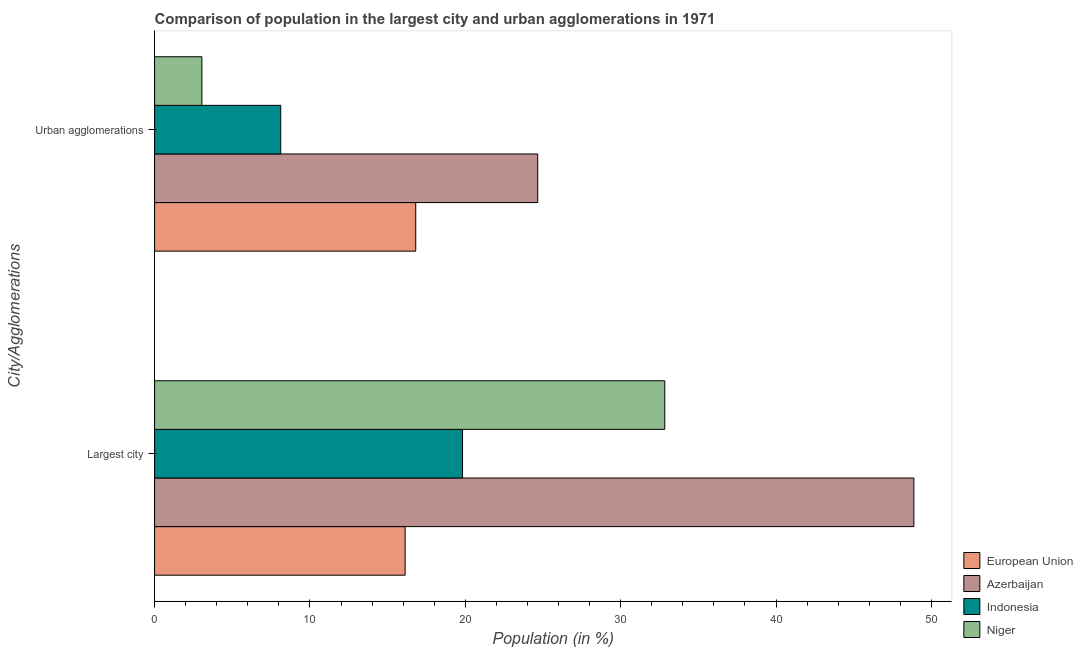How many different coloured bars are there?
Your answer should be compact. 4. Are the number of bars on each tick of the Y-axis equal?
Offer a terse response. Yes. What is the label of the 2nd group of bars from the top?
Your response must be concise. Largest city. What is the population in the largest city in Niger?
Your response must be concise. 32.84. Across all countries, what is the maximum population in urban agglomerations?
Offer a terse response. 24.66. Across all countries, what is the minimum population in the largest city?
Keep it short and to the point. 16.13. In which country was the population in urban agglomerations maximum?
Ensure brevity in your answer.  Azerbaijan. In which country was the population in urban agglomerations minimum?
Ensure brevity in your answer.  Niger. What is the total population in urban agglomerations in the graph?
Provide a short and direct response. 52.63. What is the difference between the population in the largest city in European Union and that in Indonesia?
Your answer should be compact. -3.69. What is the difference between the population in urban agglomerations in Azerbaijan and the population in the largest city in Indonesia?
Make the answer very short. 4.84. What is the average population in urban agglomerations per country?
Offer a terse response. 13.16. What is the difference between the population in urban agglomerations and population in the largest city in Indonesia?
Make the answer very short. -11.7. In how many countries, is the population in the largest city greater than 20 %?
Ensure brevity in your answer.  2. What is the ratio of the population in urban agglomerations in Azerbaijan to that in European Union?
Make the answer very short. 1.47. Is the population in the largest city in Azerbaijan less than that in European Union?
Ensure brevity in your answer.  No. What does the 1st bar from the top in Urban agglomerations represents?
Ensure brevity in your answer.  Niger. What does the 4th bar from the bottom in Largest city represents?
Keep it short and to the point. Niger. Are all the bars in the graph horizontal?
Your answer should be compact. Yes. How many countries are there in the graph?
Provide a succinct answer. 4. Are the values on the major ticks of X-axis written in scientific E-notation?
Your answer should be compact. No. Does the graph contain any zero values?
Provide a short and direct response. No. Does the graph contain grids?
Your answer should be compact. No. Where does the legend appear in the graph?
Give a very brief answer. Bottom right. What is the title of the graph?
Your answer should be very brief. Comparison of population in the largest city and urban agglomerations in 1971. Does "Nigeria" appear as one of the legend labels in the graph?
Provide a short and direct response. No. What is the label or title of the X-axis?
Keep it short and to the point. Population (in %). What is the label or title of the Y-axis?
Make the answer very short. City/Agglomerations. What is the Population (in %) in European Union in Largest city?
Provide a succinct answer. 16.13. What is the Population (in %) in Azerbaijan in Largest city?
Offer a very short reply. 48.87. What is the Population (in %) in Indonesia in Largest city?
Provide a succinct answer. 19.82. What is the Population (in %) of Niger in Largest city?
Provide a short and direct response. 32.84. What is the Population (in %) of European Union in Urban agglomerations?
Keep it short and to the point. 16.81. What is the Population (in %) in Azerbaijan in Urban agglomerations?
Give a very brief answer. 24.66. What is the Population (in %) in Indonesia in Urban agglomerations?
Keep it short and to the point. 8.12. What is the Population (in %) of Niger in Urban agglomerations?
Your response must be concise. 3.04. Across all City/Agglomerations, what is the maximum Population (in %) of European Union?
Keep it short and to the point. 16.81. Across all City/Agglomerations, what is the maximum Population (in %) in Azerbaijan?
Offer a terse response. 48.87. Across all City/Agglomerations, what is the maximum Population (in %) of Indonesia?
Offer a terse response. 19.82. Across all City/Agglomerations, what is the maximum Population (in %) of Niger?
Offer a terse response. 32.84. Across all City/Agglomerations, what is the minimum Population (in %) of European Union?
Offer a very short reply. 16.13. Across all City/Agglomerations, what is the minimum Population (in %) of Azerbaijan?
Give a very brief answer. 24.66. Across all City/Agglomerations, what is the minimum Population (in %) of Indonesia?
Make the answer very short. 8.12. Across all City/Agglomerations, what is the minimum Population (in %) of Niger?
Provide a short and direct response. 3.04. What is the total Population (in %) in European Union in the graph?
Ensure brevity in your answer.  32.94. What is the total Population (in %) of Azerbaijan in the graph?
Provide a short and direct response. 73.53. What is the total Population (in %) of Indonesia in the graph?
Offer a terse response. 27.94. What is the total Population (in %) in Niger in the graph?
Your response must be concise. 35.88. What is the difference between the Population (in %) in European Union in Largest city and that in Urban agglomerations?
Your answer should be very brief. -0.68. What is the difference between the Population (in %) in Azerbaijan in Largest city and that in Urban agglomerations?
Your answer should be compact. 24.21. What is the difference between the Population (in %) of Indonesia in Largest city and that in Urban agglomerations?
Offer a terse response. 11.7. What is the difference between the Population (in %) of Niger in Largest city and that in Urban agglomerations?
Offer a terse response. 29.79. What is the difference between the Population (in %) of European Union in Largest city and the Population (in %) of Azerbaijan in Urban agglomerations?
Provide a short and direct response. -8.53. What is the difference between the Population (in %) of European Union in Largest city and the Population (in %) of Indonesia in Urban agglomerations?
Provide a succinct answer. 8.01. What is the difference between the Population (in %) in European Union in Largest city and the Population (in %) in Niger in Urban agglomerations?
Your answer should be very brief. 13.08. What is the difference between the Population (in %) in Azerbaijan in Largest city and the Population (in %) in Indonesia in Urban agglomerations?
Offer a terse response. 40.75. What is the difference between the Population (in %) of Azerbaijan in Largest city and the Population (in %) of Niger in Urban agglomerations?
Ensure brevity in your answer.  45.82. What is the difference between the Population (in %) of Indonesia in Largest city and the Population (in %) of Niger in Urban agglomerations?
Give a very brief answer. 16.78. What is the average Population (in %) in European Union per City/Agglomerations?
Provide a short and direct response. 16.47. What is the average Population (in %) in Azerbaijan per City/Agglomerations?
Your response must be concise. 36.76. What is the average Population (in %) in Indonesia per City/Agglomerations?
Give a very brief answer. 13.97. What is the average Population (in %) in Niger per City/Agglomerations?
Offer a very short reply. 17.94. What is the difference between the Population (in %) in European Union and Population (in %) in Azerbaijan in Largest city?
Keep it short and to the point. -32.74. What is the difference between the Population (in %) of European Union and Population (in %) of Indonesia in Largest city?
Offer a very short reply. -3.69. What is the difference between the Population (in %) in European Union and Population (in %) in Niger in Largest city?
Offer a very short reply. -16.71. What is the difference between the Population (in %) of Azerbaijan and Population (in %) of Indonesia in Largest city?
Provide a short and direct response. 29.05. What is the difference between the Population (in %) of Azerbaijan and Population (in %) of Niger in Largest city?
Your answer should be very brief. 16.03. What is the difference between the Population (in %) of Indonesia and Population (in %) of Niger in Largest city?
Keep it short and to the point. -13.02. What is the difference between the Population (in %) in European Union and Population (in %) in Azerbaijan in Urban agglomerations?
Offer a terse response. -7.85. What is the difference between the Population (in %) in European Union and Population (in %) in Indonesia in Urban agglomerations?
Ensure brevity in your answer.  8.69. What is the difference between the Population (in %) of European Union and Population (in %) of Niger in Urban agglomerations?
Make the answer very short. 13.76. What is the difference between the Population (in %) in Azerbaijan and Population (in %) in Indonesia in Urban agglomerations?
Your answer should be very brief. 16.54. What is the difference between the Population (in %) of Azerbaijan and Population (in %) of Niger in Urban agglomerations?
Offer a very short reply. 21.62. What is the difference between the Population (in %) in Indonesia and Population (in %) in Niger in Urban agglomerations?
Make the answer very short. 5.08. What is the ratio of the Population (in %) in European Union in Largest city to that in Urban agglomerations?
Your response must be concise. 0.96. What is the ratio of the Population (in %) in Azerbaijan in Largest city to that in Urban agglomerations?
Provide a short and direct response. 1.98. What is the ratio of the Population (in %) of Indonesia in Largest city to that in Urban agglomerations?
Your answer should be very brief. 2.44. What is the ratio of the Population (in %) in Niger in Largest city to that in Urban agglomerations?
Your response must be concise. 10.79. What is the difference between the highest and the second highest Population (in %) in European Union?
Provide a succinct answer. 0.68. What is the difference between the highest and the second highest Population (in %) in Azerbaijan?
Provide a succinct answer. 24.21. What is the difference between the highest and the second highest Population (in %) in Indonesia?
Provide a succinct answer. 11.7. What is the difference between the highest and the second highest Population (in %) in Niger?
Give a very brief answer. 29.79. What is the difference between the highest and the lowest Population (in %) in European Union?
Ensure brevity in your answer.  0.68. What is the difference between the highest and the lowest Population (in %) of Azerbaijan?
Your answer should be compact. 24.21. What is the difference between the highest and the lowest Population (in %) of Indonesia?
Offer a very short reply. 11.7. What is the difference between the highest and the lowest Population (in %) of Niger?
Provide a succinct answer. 29.79. 